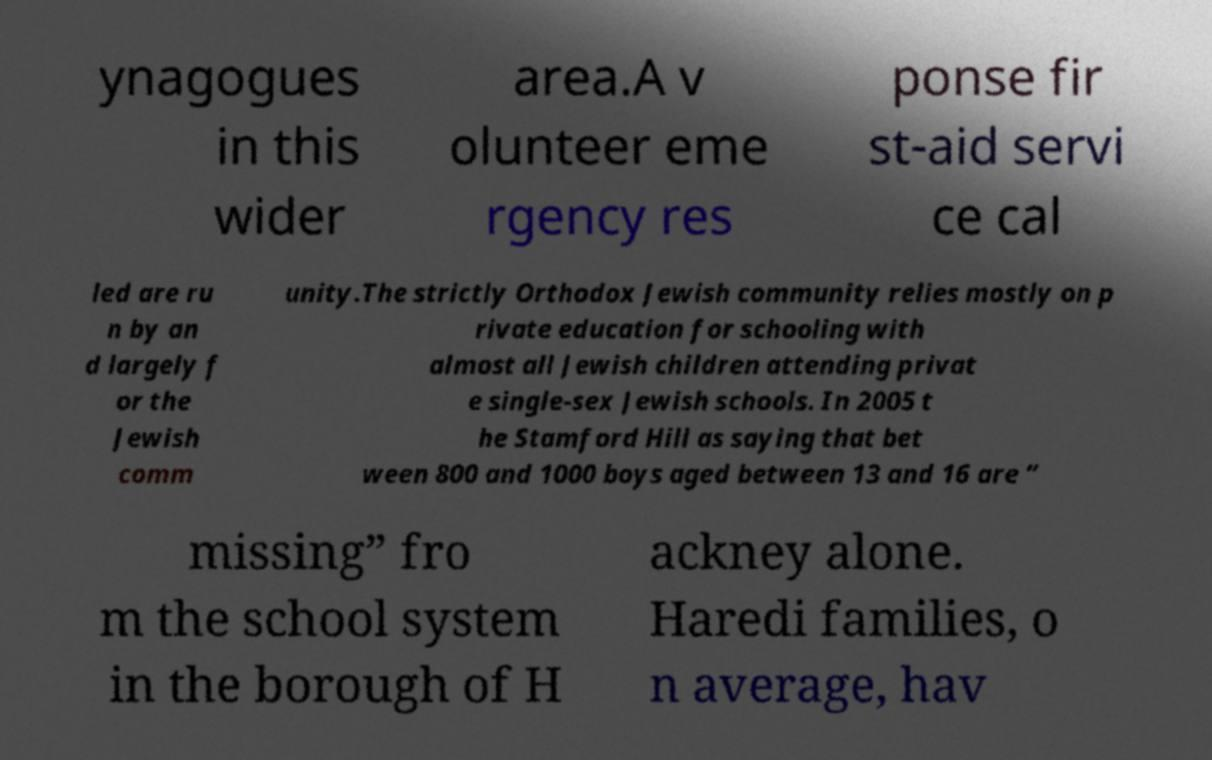For documentation purposes, I need the text within this image transcribed. Could you provide that? ynagogues in this wider area.A v olunteer eme rgency res ponse fir st-aid servi ce cal led are ru n by an d largely f or the Jewish comm unity.The strictly Orthodox Jewish community relies mostly on p rivate education for schooling with almost all Jewish children attending privat e single-sex Jewish schools. In 2005 t he Stamford Hill as saying that bet ween 800 and 1000 boys aged between 13 and 16 are “ missing” fro m the school system in the borough of H ackney alone. Haredi families, o n average, hav 